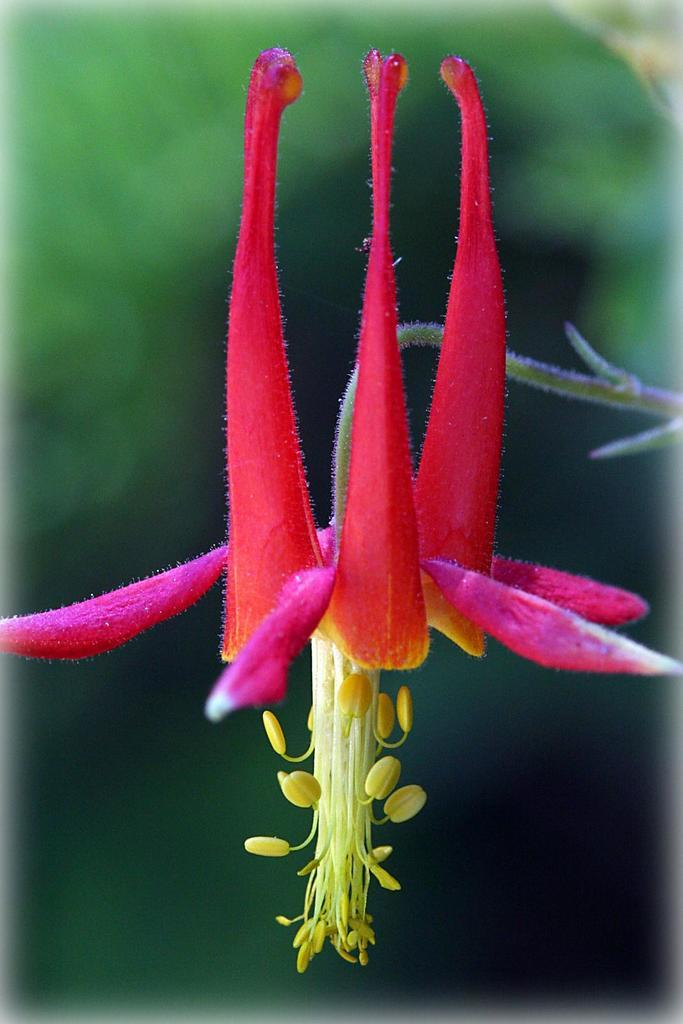What is the main subject of the image? There is a flower in the image. Can you describe the background of the image? The background of the image is blurry. What else can be seen in the image besides the flower? There are pollen grains in the image. How many veins can be seen in the flower in the image? There is no mention of veins in the flower in the provided facts, so it cannot be determined from the image. 